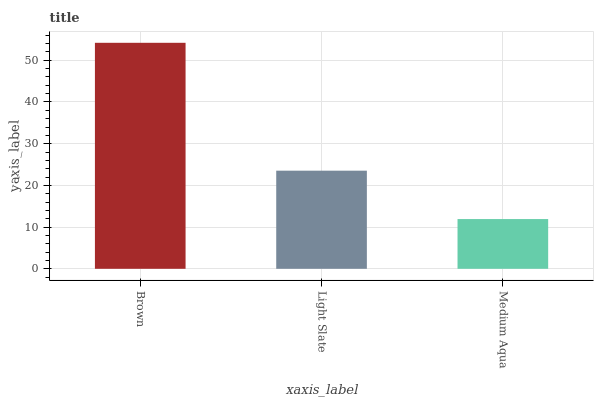Is Medium Aqua the minimum?
Answer yes or no. Yes. Is Brown the maximum?
Answer yes or no. Yes. Is Light Slate the minimum?
Answer yes or no. No. Is Light Slate the maximum?
Answer yes or no. No. Is Brown greater than Light Slate?
Answer yes or no. Yes. Is Light Slate less than Brown?
Answer yes or no. Yes. Is Light Slate greater than Brown?
Answer yes or no. No. Is Brown less than Light Slate?
Answer yes or no. No. Is Light Slate the high median?
Answer yes or no. Yes. Is Light Slate the low median?
Answer yes or no. Yes. Is Brown the high median?
Answer yes or no. No. Is Brown the low median?
Answer yes or no. No. 